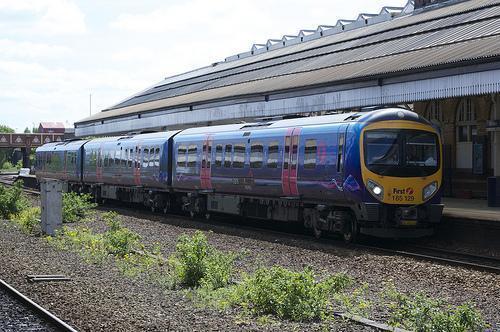How many trains are there?
Give a very brief answer. 1. 